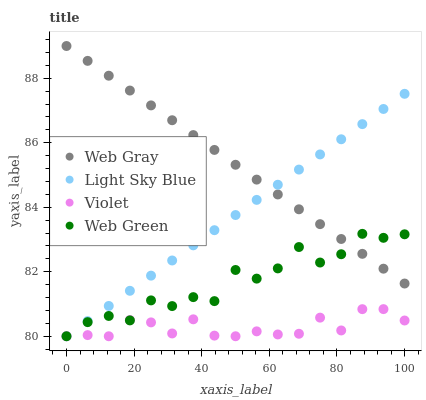Does Violet have the minimum area under the curve?
Answer yes or no. Yes. Does Web Gray have the maximum area under the curve?
Answer yes or no. Yes. Does Web Green have the minimum area under the curve?
Answer yes or no. No. Does Web Green have the maximum area under the curve?
Answer yes or no. No. Is Web Gray the smoothest?
Answer yes or no. Yes. Is Web Green the roughest?
Answer yes or no. Yes. Is Light Sky Blue the smoothest?
Answer yes or no. No. Is Light Sky Blue the roughest?
Answer yes or no. No. Does Web Green have the lowest value?
Answer yes or no. Yes. Does Web Gray have the highest value?
Answer yes or no. Yes. Does Web Green have the highest value?
Answer yes or no. No. Is Violet less than Web Gray?
Answer yes or no. Yes. Is Web Gray greater than Violet?
Answer yes or no. Yes. Does Light Sky Blue intersect Web Gray?
Answer yes or no. Yes. Is Light Sky Blue less than Web Gray?
Answer yes or no. No. Is Light Sky Blue greater than Web Gray?
Answer yes or no. No. Does Violet intersect Web Gray?
Answer yes or no. No. 